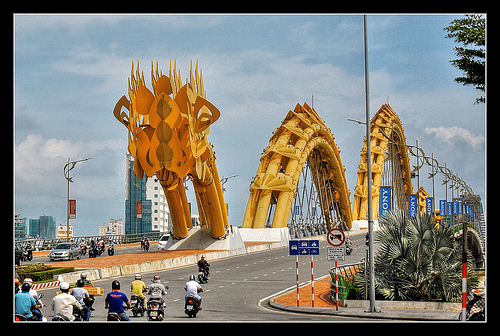<image>
Is there a bush under the sign? No. The bush is not positioned under the sign. The vertical relationship between these objects is different. 